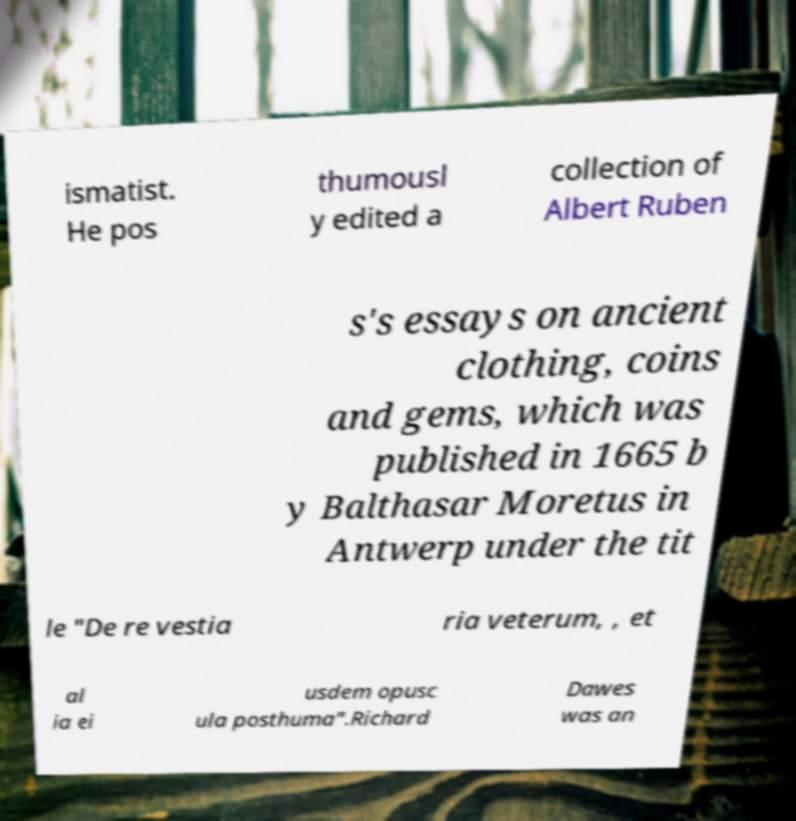Could you assist in decoding the text presented in this image and type it out clearly? ismatist. He pos thumousl y edited a collection of Albert Ruben s's essays on ancient clothing, coins and gems, which was published in 1665 b y Balthasar Moretus in Antwerp under the tit le "De re vestia ria veterum, , et al ia ei usdem opusc ula posthuma".Richard Dawes was an 